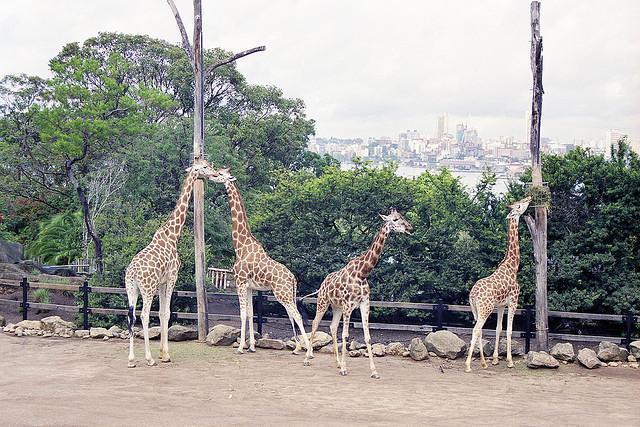How many giraffes are there?
Give a very brief answer. 4. How many giraffes are in the photo?
Give a very brief answer. 4. How many signs have bus icon on a pole?
Give a very brief answer. 0. 